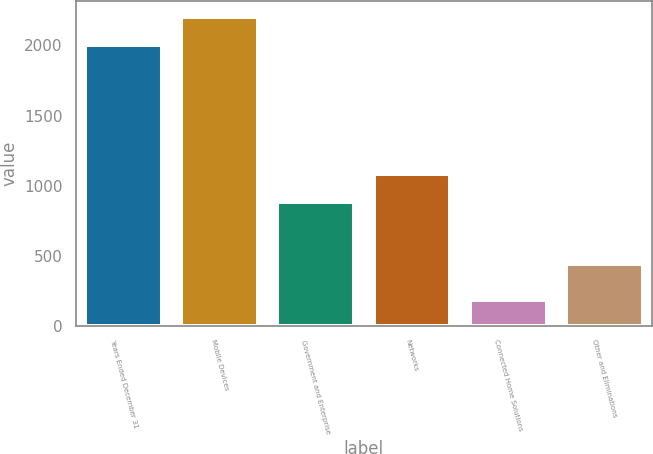Convert chart to OTSL. <chart><loc_0><loc_0><loc_500><loc_500><bar_chart><fcel>Years Ended December 31<fcel>Mobile Devices<fcel>Government and Enterprise<fcel>Networks<fcel>Connected Home Solutions<fcel>Other and Eliminations<nl><fcel>2005<fcel>2206.3<fcel>882<fcel>1083.3<fcel>185<fcel>441<nl></chart> 